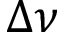<formula> <loc_0><loc_0><loc_500><loc_500>\Delta \nu</formula> 